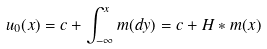Convert formula to latex. <formula><loc_0><loc_0><loc_500><loc_500>u _ { 0 } ( x ) = c + \int _ { - \infty } ^ { x } m ( d y ) = c + H * m ( x )</formula> 